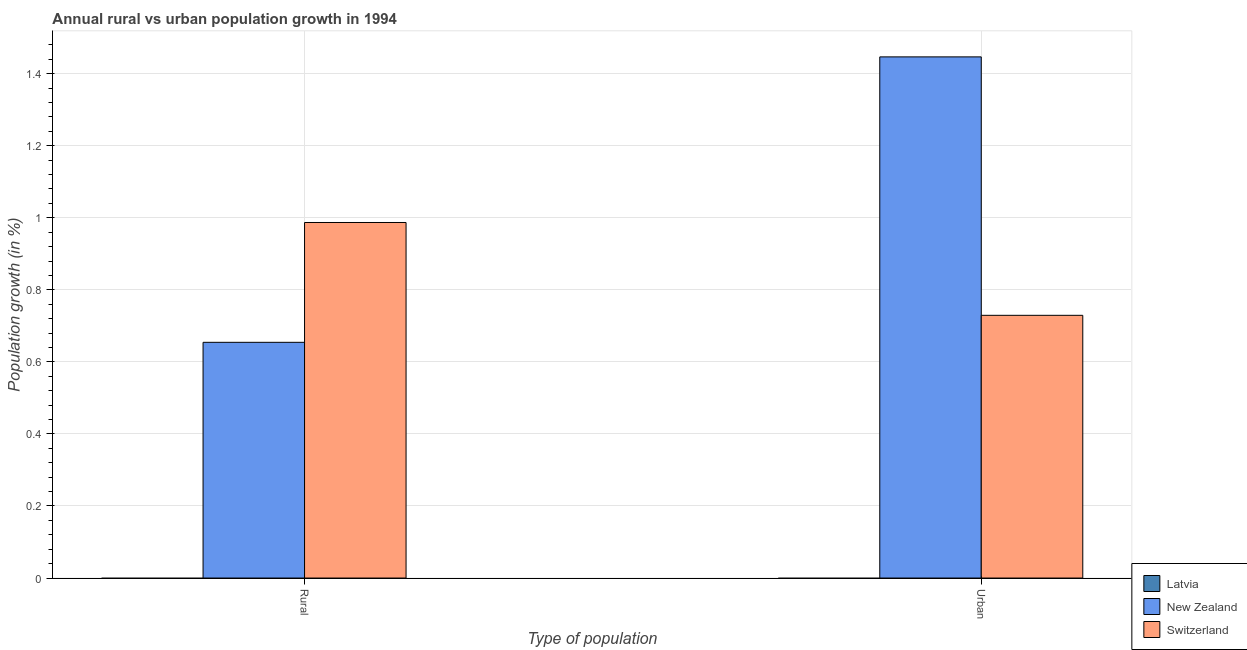Are the number of bars per tick equal to the number of legend labels?
Your response must be concise. No. Are the number of bars on each tick of the X-axis equal?
Provide a succinct answer. Yes. How many bars are there on the 1st tick from the left?
Ensure brevity in your answer.  2. How many bars are there on the 2nd tick from the right?
Your answer should be compact. 2. What is the label of the 2nd group of bars from the left?
Your answer should be very brief. Urban . What is the rural population growth in Switzerland?
Ensure brevity in your answer.  0.99. Across all countries, what is the maximum rural population growth?
Your response must be concise. 0.99. In which country was the urban population growth maximum?
Your response must be concise. New Zealand. What is the total urban population growth in the graph?
Make the answer very short. 2.18. What is the difference between the rural population growth in Switzerland and that in New Zealand?
Your answer should be compact. 0.33. What is the difference between the urban population growth in Switzerland and the rural population growth in New Zealand?
Provide a succinct answer. 0.07. What is the average rural population growth per country?
Ensure brevity in your answer.  0.55. What is the difference between the urban population growth and rural population growth in New Zealand?
Ensure brevity in your answer.  0.79. In how many countries, is the urban population growth greater than 1.04 %?
Offer a very short reply. 1. What is the ratio of the rural population growth in New Zealand to that in Switzerland?
Provide a succinct answer. 0.66. In how many countries, is the urban population growth greater than the average urban population growth taken over all countries?
Offer a very short reply. 2. How many bars are there?
Provide a short and direct response. 4. What is the difference between two consecutive major ticks on the Y-axis?
Offer a terse response. 0.2. Does the graph contain any zero values?
Keep it short and to the point. Yes. Does the graph contain grids?
Make the answer very short. Yes. Where does the legend appear in the graph?
Give a very brief answer. Bottom right. How many legend labels are there?
Offer a terse response. 3. How are the legend labels stacked?
Provide a succinct answer. Vertical. What is the title of the graph?
Keep it short and to the point. Annual rural vs urban population growth in 1994. What is the label or title of the X-axis?
Your response must be concise. Type of population. What is the label or title of the Y-axis?
Your answer should be very brief. Population growth (in %). What is the Population growth (in %) in Latvia in Rural?
Offer a very short reply. 0. What is the Population growth (in %) of New Zealand in Rural?
Keep it short and to the point. 0.65. What is the Population growth (in %) of Switzerland in Rural?
Keep it short and to the point. 0.99. What is the Population growth (in %) of Latvia in Urban ?
Provide a succinct answer. 0. What is the Population growth (in %) of New Zealand in Urban ?
Your answer should be compact. 1.45. What is the Population growth (in %) of Switzerland in Urban ?
Give a very brief answer. 0.73. Across all Type of population, what is the maximum Population growth (in %) of New Zealand?
Ensure brevity in your answer.  1.45. Across all Type of population, what is the maximum Population growth (in %) of Switzerland?
Your response must be concise. 0.99. Across all Type of population, what is the minimum Population growth (in %) of New Zealand?
Keep it short and to the point. 0.65. Across all Type of population, what is the minimum Population growth (in %) of Switzerland?
Ensure brevity in your answer.  0.73. What is the total Population growth (in %) of New Zealand in the graph?
Your answer should be compact. 2.1. What is the total Population growth (in %) in Switzerland in the graph?
Your answer should be very brief. 1.72. What is the difference between the Population growth (in %) in New Zealand in Rural and that in Urban ?
Offer a terse response. -0.79. What is the difference between the Population growth (in %) in Switzerland in Rural and that in Urban ?
Your answer should be compact. 0.26. What is the difference between the Population growth (in %) in New Zealand in Rural and the Population growth (in %) in Switzerland in Urban?
Your response must be concise. -0.07. What is the average Population growth (in %) of Latvia per Type of population?
Provide a succinct answer. 0. What is the average Population growth (in %) of New Zealand per Type of population?
Your answer should be compact. 1.05. What is the average Population growth (in %) of Switzerland per Type of population?
Offer a terse response. 0.86. What is the difference between the Population growth (in %) in New Zealand and Population growth (in %) in Switzerland in Rural?
Your response must be concise. -0.33. What is the difference between the Population growth (in %) in New Zealand and Population growth (in %) in Switzerland in Urban ?
Ensure brevity in your answer.  0.72. What is the ratio of the Population growth (in %) in New Zealand in Rural to that in Urban ?
Your response must be concise. 0.45. What is the ratio of the Population growth (in %) in Switzerland in Rural to that in Urban ?
Your response must be concise. 1.35. What is the difference between the highest and the second highest Population growth (in %) of New Zealand?
Offer a terse response. 0.79. What is the difference between the highest and the second highest Population growth (in %) of Switzerland?
Your response must be concise. 0.26. What is the difference between the highest and the lowest Population growth (in %) of New Zealand?
Provide a short and direct response. 0.79. What is the difference between the highest and the lowest Population growth (in %) in Switzerland?
Your response must be concise. 0.26. 